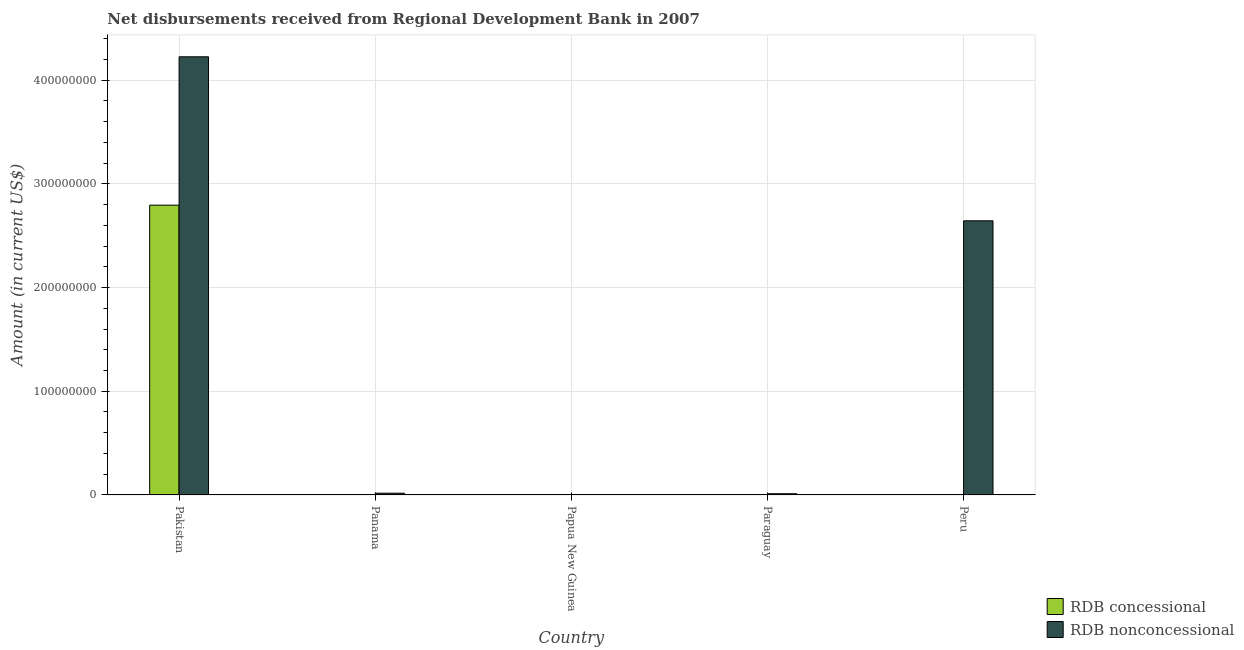Are the number of bars per tick equal to the number of legend labels?
Your answer should be very brief. No. How many bars are there on the 3rd tick from the right?
Keep it short and to the point. 0. What is the label of the 2nd group of bars from the left?
Provide a short and direct response. Panama. In how many cases, is the number of bars for a given country not equal to the number of legend labels?
Provide a succinct answer. 4. Across all countries, what is the maximum net non concessional disbursements from rdb?
Keep it short and to the point. 4.23e+08. In which country was the net non concessional disbursements from rdb maximum?
Offer a terse response. Pakistan. What is the total net non concessional disbursements from rdb in the graph?
Your answer should be very brief. 6.90e+08. What is the difference between the net non concessional disbursements from rdb in Panama and that in Peru?
Make the answer very short. -2.63e+08. What is the difference between the net concessional disbursements from rdb in Panama and the net non concessional disbursements from rdb in Pakistan?
Ensure brevity in your answer.  -4.23e+08. What is the average net concessional disbursements from rdb per country?
Offer a very short reply. 5.59e+07. What is the difference between the net non concessional disbursements from rdb and net concessional disbursements from rdb in Pakistan?
Keep it short and to the point. 1.43e+08. What is the ratio of the net non concessional disbursements from rdb in Pakistan to that in Peru?
Make the answer very short. 1.6. What is the difference between the highest and the second highest net non concessional disbursements from rdb?
Keep it short and to the point. 1.58e+08. What is the difference between the highest and the lowest net non concessional disbursements from rdb?
Your answer should be very brief. 4.23e+08. How many bars are there?
Give a very brief answer. 5. Are all the bars in the graph horizontal?
Make the answer very short. No. How many countries are there in the graph?
Your answer should be compact. 5. Where does the legend appear in the graph?
Provide a succinct answer. Bottom right. How many legend labels are there?
Offer a very short reply. 2. How are the legend labels stacked?
Offer a very short reply. Vertical. What is the title of the graph?
Give a very brief answer. Net disbursements received from Regional Development Bank in 2007. Does "Broad money growth" appear as one of the legend labels in the graph?
Ensure brevity in your answer.  No. What is the label or title of the X-axis?
Provide a short and direct response. Country. What is the label or title of the Y-axis?
Make the answer very short. Amount (in current US$). What is the Amount (in current US$) of RDB concessional in Pakistan?
Provide a succinct answer. 2.79e+08. What is the Amount (in current US$) of RDB nonconcessional in Pakistan?
Provide a succinct answer. 4.23e+08. What is the Amount (in current US$) of RDB nonconcessional in Panama?
Provide a succinct answer. 1.66e+06. What is the Amount (in current US$) in RDB nonconcessional in Paraguay?
Your answer should be very brief. 1.15e+06. What is the Amount (in current US$) of RDB nonconcessional in Peru?
Your response must be concise. 2.64e+08. Across all countries, what is the maximum Amount (in current US$) of RDB concessional?
Your response must be concise. 2.79e+08. Across all countries, what is the maximum Amount (in current US$) in RDB nonconcessional?
Your answer should be compact. 4.23e+08. Across all countries, what is the minimum Amount (in current US$) of RDB concessional?
Your response must be concise. 0. What is the total Amount (in current US$) in RDB concessional in the graph?
Your response must be concise. 2.79e+08. What is the total Amount (in current US$) in RDB nonconcessional in the graph?
Your answer should be compact. 6.90e+08. What is the difference between the Amount (in current US$) in RDB nonconcessional in Pakistan and that in Panama?
Provide a succinct answer. 4.21e+08. What is the difference between the Amount (in current US$) in RDB nonconcessional in Pakistan and that in Paraguay?
Your response must be concise. 4.21e+08. What is the difference between the Amount (in current US$) of RDB nonconcessional in Pakistan and that in Peru?
Your response must be concise. 1.58e+08. What is the difference between the Amount (in current US$) of RDB nonconcessional in Panama and that in Paraguay?
Provide a succinct answer. 5.05e+05. What is the difference between the Amount (in current US$) of RDB nonconcessional in Panama and that in Peru?
Your response must be concise. -2.63e+08. What is the difference between the Amount (in current US$) in RDB nonconcessional in Paraguay and that in Peru?
Offer a very short reply. -2.63e+08. What is the difference between the Amount (in current US$) in RDB concessional in Pakistan and the Amount (in current US$) in RDB nonconcessional in Panama?
Your answer should be compact. 2.78e+08. What is the difference between the Amount (in current US$) of RDB concessional in Pakistan and the Amount (in current US$) of RDB nonconcessional in Paraguay?
Offer a very short reply. 2.78e+08. What is the difference between the Amount (in current US$) in RDB concessional in Pakistan and the Amount (in current US$) in RDB nonconcessional in Peru?
Ensure brevity in your answer.  1.51e+07. What is the average Amount (in current US$) of RDB concessional per country?
Give a very brief answer. 5.59e+07. What is the average Amount (in current US$) of RDB nonconcessional per country?
Offer a very short reply. 1.38e+08. What is the difference between the Amount (in current US$) of RDB concessional and Amount (in current US$) of RDB nonconcessional in Pakistan?
Ensure brevity in your answer.  -1.43e+08. What is the ratio of the Amount (in current US$) of RDB nonconcessional in Pakistan to that in Panama?
Your answer should be very brief. 255.29. What is the ratio of the Amount (in current US$) of RDB nonconcessional in Pakistan to that in Paraguay?
Your answer should be very brief. 367.4. What is the ratio of the Amount (in current US$) of RDB nonconcessional in Pakistan to that in Peru?
Offer a terse response. 1.6. What is the ratio of the Amount (in current US$) of RDB nonconcessional in Panama to that in Paraguay?
Keep it short and to the point. 1.44. What is the ratio of the Amount (in current US$) of RDB nonconcessional in Panama to that in Peru?
Make the answer very short. 0.01. What is the ratio of the Amount (in current US$) in RDB nonconcessional in Paraguay to that in Peru?
Ensure brevity in your answer.  0. What is the difference between the highest and the second highest Amount (in current US$) in RDB nonconcessional?
Your answer should be compact. 1.58e+08. What is the difference between the highest and the lowest Amount (in current US$) in RDB concessional?
Your response must be concise. 2.79e+08. What is the difference between the highest and the lowest Amount (in current US$) of RDB nonconcessional?
Offer a very short reply. 4.23e+08. 